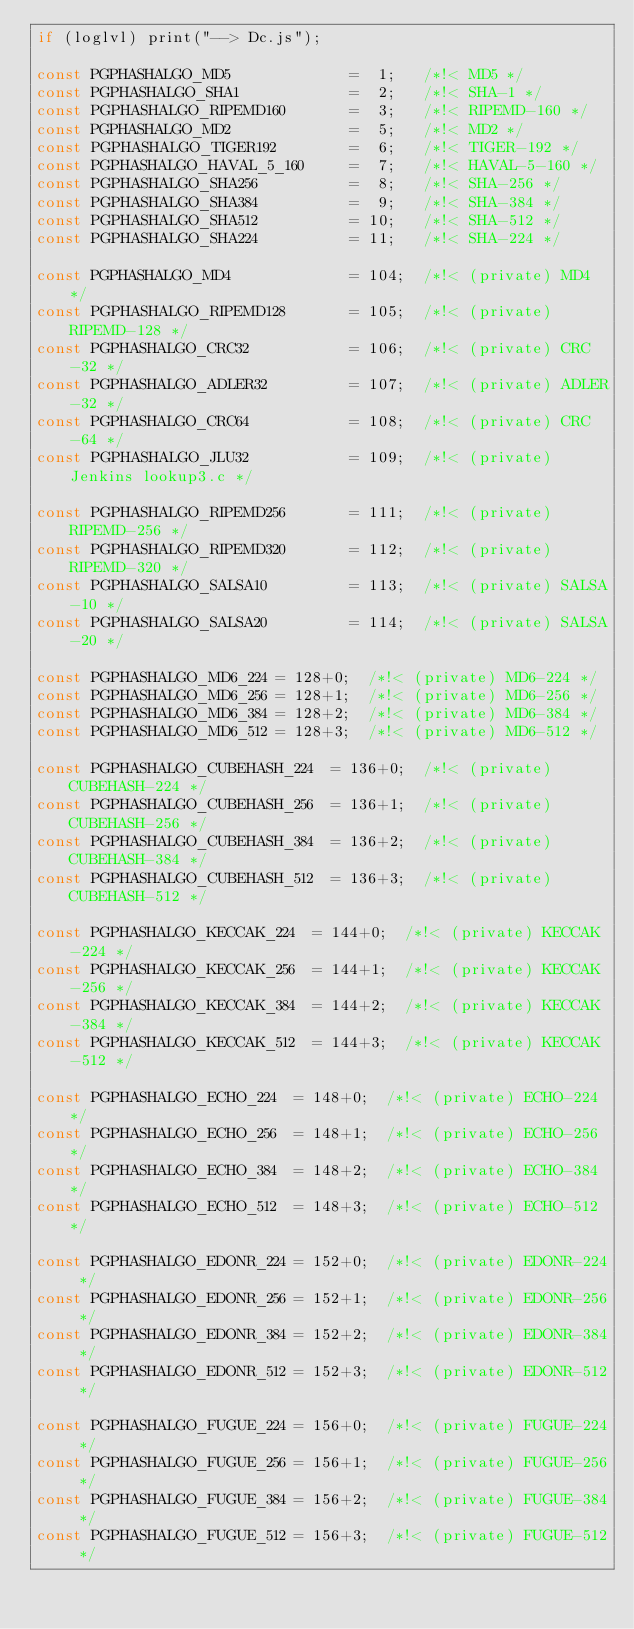Convert code to text. <code><loc_0><loc_0><loc_500><loc_500><_JavaScript_>if (loglvl) print("--> Dc.js");

const PGPHASHALGO_MD5             =  1;   /*!< MD5 */
const PGPHASHALGO_SHA1            =  2;   /*!< SHA-1 */
const PGPHASHALGO_RIPEMD160       =  3;   /*!< RIPEMD-160 */
const PGPHASHALGO_MD2             =  5;   /*!< MD2 */
const PGPHASHALGO_TIGER192        =  6;   /*!< TIGER-192 */
const PGPHASHALGO_HAVAL_5_160     =  7;   /*!< HAVAL-5-160 */
const PGPHASHALGO_SHA256          =  8;   /*!< SHA-256 */
const PGPHASHALGO_SHA384          =  9;   /*!< SHA-384 */
const PGPHASHALGO_SHA512          = 10;   /*!< SHA-512 */
const PGPHASHALGO_SHA224          = 11;   /*!< SHA-224 */

const PGPHASHALGO_MD4             = 104;  /*!< (private) MD4 */
const PGPHASHALGO_RIPEMD128       = 105;  /*!< (private) RIPEMD-128 */
const PGPHASHALGO_CRC32           = 106;  /*!< (private) CRC-32 */
const PGPHASHALGO_ADLER32         = 107;  /*!< (private) ADLER-32 */
const PGPHASHALGO_CRC64           = 108;  /*!< (private) CRC-64 */
const PGPHASHALGO_JLU32           = 109;  /*!< (private) Jenkins lookup3.c */

const PGPHASHALGO_RIPEMD256       = 111;  /*!< (private) RIPEMD-256 */
const PGPHASHALGO_RIPEMD320       = 112;  /*!< (private) RIPEMD-320 */
const PGPHASHALGO_SALSA10         = 113;  /*!< (private) SALSA-10 */
const PGPHASHALGO_SALSA20         = 114;  /*!< (private) SALSA-20 */

const PGPHASHALGO_MD6_224	= 128+0;	/*!< (private) MD6-224 */
const PGPHASHALGO_MD6_256	= 128+1;	/*!< (private) MD6-256 */
const PGPHASHALGO_MD6_384	= 128+2;	/*!< (private) MD6-384 */
const PGPHASHALGO_MD6_512	= 128+3;	/*!< (private) MD6-512 */

const PGPHASHALGO_CUBEHASH_224	= 136+0;	/*!< (private) CUBEHASH-224 */
const PGPHASHALGO_CUBEHASH_256	= 136+1;	/*!< (private) CUBEHASH-256 */
const PGPHASHALGO_CUBEHASH_384	= 136+2;	/*!< (private) CUBEHASH-384 */
const PGPHASHALGO_CUBEHASH_512	= 136+3;	/*!< (private) CUBEHASH-512 */

const PGPHASHALGO_KECCAK_224	= 144+0;	/*!< (private) KECCAK-224 */
const PGPHASHALGO_KECCAK_256	= 144+1;	/*!< (private) KECCAK-256 */
const PGPHASHALGO_KECCAK_384	= 144+2;	/*!< (private) KECCAK-384 */
const PGPHASHALGO_KECCAK_512	= 144+3;	/*!< (private) KECCAK-512 */

const PGPHASHALGO_ECHO_224	= 148+0;	/*!< (private) ECHO-224 */
const PGPHASHALGO_ECHO_256	= 148+1;	/*!< (private) ECHO-256 */
const PGPHASHALGO_ECHO_384	= 148+2;	/*!< (private) ECHO-384 */
const PGPHASHALGO_ECHO_512	= 148+3;	/*!< (private) ECHO-512 */

const PGPHASHALGO_EDONR_224	= 152+0;	/*!< (private) EDONR-224 */
const PGPHASHALGO_EDONR_256	= 152+1;	/*!< (private) EDONR-256 */
const PGPHASHALGO_EDONR_384	= 152+2;	/*!< (private) EDONR-384 */
const PGPHASHALGO_EDONR_512	= 152+3;	/*!< (private) EDONR-512 */

const PGPHASHALGO_FUGUE_224	= 156+0;	/*!< (private) FUGUE-224 */
const PGPHASHALGO_FUGUE_256	= 156+1;	/*!< (private) FUGUE-256 */
const PGPHASHALGO_FUGUE_384	= 156+2;	/*!< (private) FUGUE-384 */
const PGPHASHALGO_FUGUE_512	= 156+3;	/*!< (private) FUGUE-512 */
</code> 